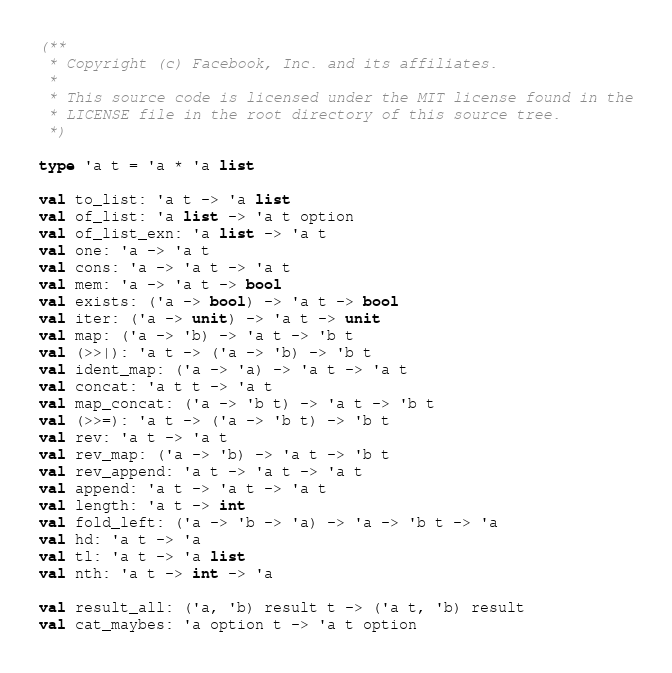<code> <loc_0><loc_0><loc_500><loc_500><_OCaml_>(**
 * Copyright (c) Facebook, Inc. and its affiliates.
 *
 * This source code is licensed under the MIT license found in the
 * LICENSE file in the root directory of this source tree.
 *)

type 'a t = 'a * 'a list

val to_list: 'a t -> 'a list
val of_list: 'a list -> 'a t option
val of_list_exn: 'a list -> 'a t
val one: 'a -> 'a t
val cons: 'a -> 'a t -> 'a t
val mem: 'a -> 'a t -> bool
val exists: ('a -> bool) -> 'a t -> bool
val iter: ('a -> unit) -> 'a t -> unit
val map: ('a -> 'b) -> 'a t -> 'b t
val (>>|): 'a t -> ('a -> 'b) -> 'b t
val ident_map: ('a -> 'a) -> 'a t -> 'a t
val concat: 'a t t -> 'a t
val map_concat: ('a -> 'b t) -> 'a t -> 'b t
val (>>=): 'a t -> ('a -> 'b t) -> 'b t
val rev: 'a t -> 'a t
val rev_map: ('a -> 'b) -> 'a t -> 'b t
val rev_append: 'a t -> 'a t -> 'a t
val append: 'a t -> 'a t -> 'a t
val length: 'a t -> int
val fold_left: ('a -> 'b -> 'a) -> 'a -> 'b t -> 'a
val hd: 'a t -> 'a
val tl: 'a t -> 'a list
val nth: 'a t -> int -> 'a

val result_all: ('a, 'b) result t -> ('a t, 'b) result
val cat_maybes: 'a option t -> 'a t option
</code> 